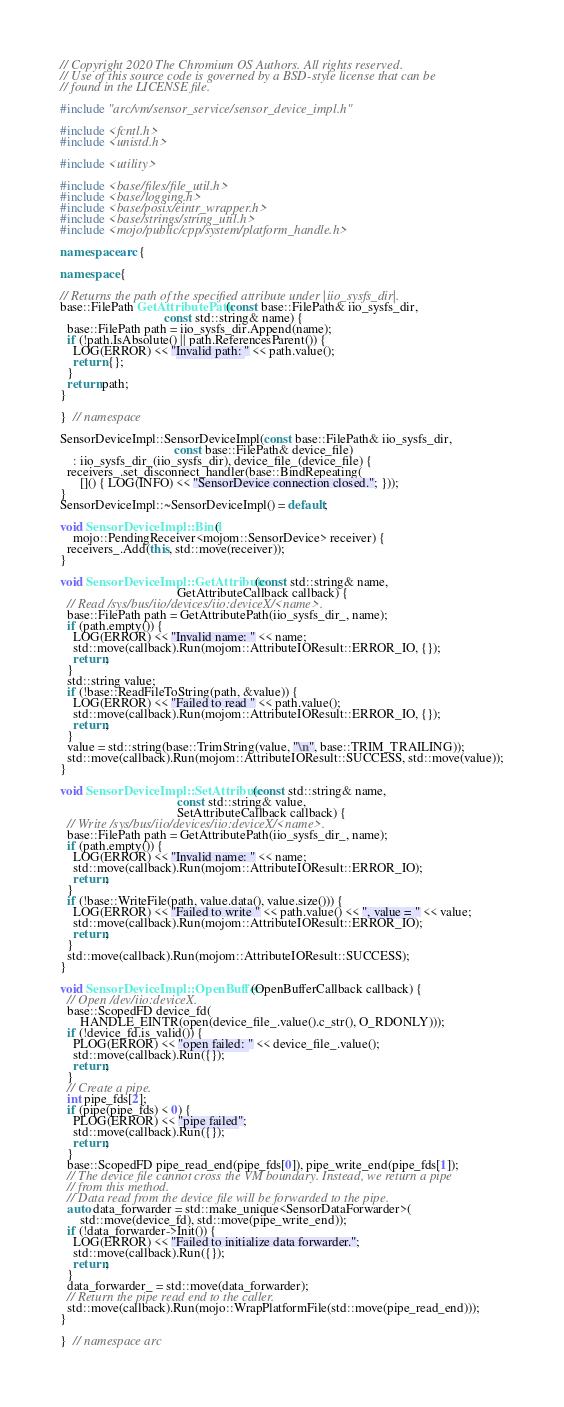Convert code to text. <code><loc_0><loc_0><loc_500><loc_500><_C++_>// Copyright 2020 The Chromium OS Authors. All rights reserved.
// Use of this source code is governed by a BSD-style license that can be
// found in the LICENSE file.

#include "arc/vm/sensor_service/sensor_device_impl.h"

#include <fcntl.h>
#include <unistd.h>

#include <utility>

#include <base/files/file_util.h>
#include <base/logging.h>
#include <base/posix/eintr_wrapper.h>
#include <base/strings/string_util.h>
#include <mojo/public/cpp/system/platform_handle.h>

namespace arc {

namespace {

// Returns the path of the specified attribute under |iio_sysfs_dir|.
base::FilePath GetAttributePath(const base::FilePath& iio_sysfs_dir,
                                const std::string& name) {
  base::FilePath path = iio_sysfs_dir.Append(name);
  if (!path.IsAbsolute() || path.ReferencesParent()) {
    LOG(ERROR) << "Invalid path: " << path.value();
    return {};
  }
  return path;
}

}  // namespace

SensorDeviceImpl::SensorDeviceImpl(const base::FilePath& iio_sysfs_dir,
                                   const base::FilePath& device_file)
    : iio_sysfs_dir_(iio_sysfs_dir), device_file_(device_file) {
  receivers_.set_disconnect_handler(base::BindRepeating(
      []() { LOG(INFO) << "SensorDevice connection closed."; }));
}
SensorDeviceImpl::~SensorDeviceImpl() = default;

void SensorDeviceImpl::Bind(
    mojo::PendingReceiver<mojom::SensorDevice> receiver) {
  receivers_.Add(this, std::move(receiver));
}

void SensorDeviceImpl::GetAttribute(const std::string& name,
                                    GetAttributeCallback callback) {
  // Read /sys/bus/iio/devices/iio:deviceX/<name>.
  base::FilePath path = GetAttributePath(iio_sysfs_dir_, name);
  if (path.empty()) {
    LOG(ERROR) << "Invalid name: " << name;
    std::move(callback).Run(mojom::AttributeIOResult::ERROR_IO, {});
    return;
  }
  std::string value;
  if (!base::ReadFileToString(path, &value)) {
    LOG(ERROR) << "Failed to read " << path.value();
    std::move(callback).Run(mojom::AttributeIOResult::ERROR_IO, {});
    return;
  }
  value = std::string(base::TrimString(value, "\n", base::TRIM_TRAILING));
  std::move(callback).Run(mojom::AttributeIOResult::SUCCESS, std::move(value));
}

void SensorDeviceImpl::SetAttribute(const std::string& name,
                                    const std::string& value,
                                    SetAttributeCallback callback) {
  // Write /sys/bus/iio/devices/iio:deviceX/<name>.
  base::FilePath path = GetAttributePath(iio_sysfs_dir_, name);
  if (path.empty()) {
    LOG(ERROR) << "Invalid name: " << name;
    std::move(callback).Run(mojom::AttributeIOResult::ERROR_IO);
    return;
  }
  if (!base::WriteFile(path, value.data(), value.size())) {
    LOG(ERROR) << "Failed to write " << path.value() << ", value = " << value;
    std::move(callback).Run(mojom::AttributeIOResult::ERROR_IO);
    return;
  }
  std::move(callback).Run(mojom::AttributeIOResult::SUCCESS);
}

void SensorDeviceImpl::OpenBuffer(OpenBufferCallback callback) {
  // Open /dev/iio:deviceX.
  base::ScopedFD device_fd(
      HANDLE_EINTR(open(device_file_.value().c_str(), O_RDONLY)));
  if (!device_fd.is_valid()) {
    PLOG(ERROR) << "open failed: " << device_file_.value();
    std::move(callback).Run({});
    return;
  }
  // Create a pipe.
  int pipe_fds[2];
  if (pipe(pipe_fds) < 0) {
    PLOG(ERROR) << "pipe failed";
    std::move(callback).Run({});
    return;
  }
  base::ScopedFD pipe_read_end(pipe_fds[0]), pipe_write_end(pipe_fds[1]);
  // The device file cannot cross the VM boundary. Instead, we return a pipe
  // from this method.
  // Data read from the device file will be forwarded to the pipe.
  auto data_forwarder = std::make_unique<SensorDataForwarder>(
      std::move(device_fd), std::move(pipe_write_end));
  if (!data_forwarder->Init()) {
    LOG(ERROR) << "Failed to initialize data forwarder.";
    std::move(callback).Run({});
    return;
  }
  data_forwarder_ = std::move(data_forwarder);
  // Return the pipe read end to the caller.
  std::move(callback).Run(mojo::WrapPlatformFile(std::move(pipe_read_end)));
}

}  // namespace arc
</code> 